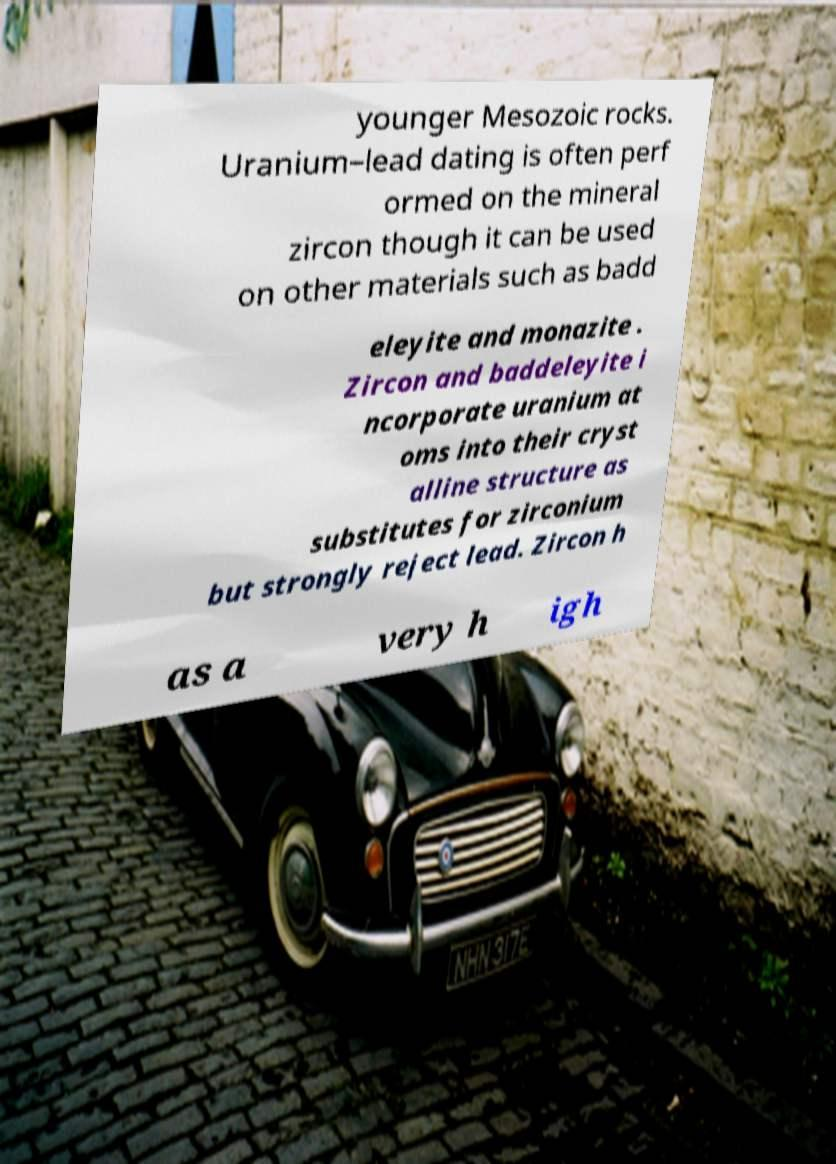Could you extract and type out the text from this image? younger Mesozoic rocks. Uranium–lead dating is often perf ormed on the mineral zircon though it can be used on other materials such as badd eleyite and monazite . Zircon and baddeleyite i ncorporate uranium at oms into their cryst alline structure as substitutes for zirconium but strongly reject lead. Zircon h as a very h igh 